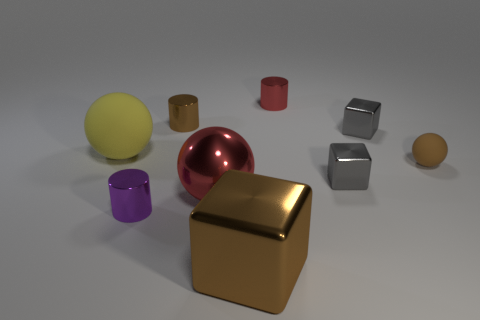What is the brown cube made of?
Provide a succinct answer. Metal. The purple metal object that is the same size as the brown rubber sphere is what shape?
Make the answer very short. Cylinder. Does the block in front of the purple shiny cylinder have the same material as the sphere that is to the right of the small red cylinder?
Make the answer very short. No. How many small red shiny cubes are there?
Keep it short and to the point. 0. What number of other purple things have the same shape as the small purple object?
Your answer should be compact. 0. Is the shape of the yellow object the same as the tiny brown matte thing?
Make the answer very short. Yes. The brown rubber ball has what size?
Offer a very short reply. Small. What number of green cylinders are the same size as the brown matte ball?
Keep it short and to the point. 0. There is a shiny cube that is left of the red cylinder; is its size the same as the brown matte object on the right side of the big yellow sphere?
Provide a succinct answer. No. There is a brown shiny object that is in front of the small purple shiny object; what is its shape?
Offer a very short reply. Cube. 